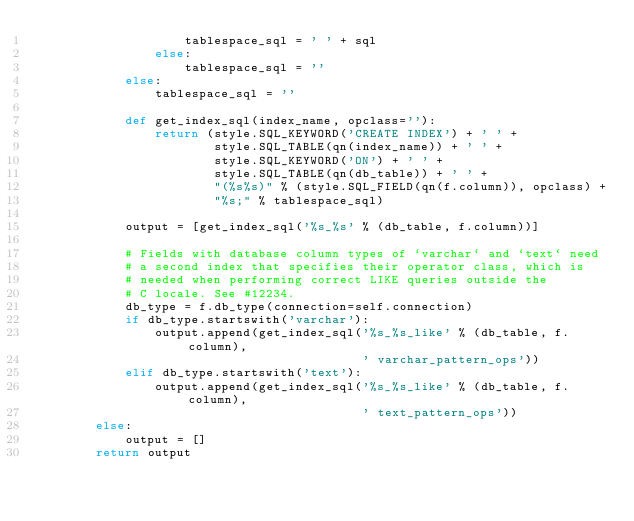<code> <loc_0><loc_0><loc_500><loc_500><_Python_>                    tablespace_sql = ' ' + sql
                else:
                    tablespace_sql = ''
            else:
                tablespace_sql = ''

            def get_index_sql(index_name, opclass=''):
                return (style.SQL_KEYWORD('CREATE INDEX') + ' ' +
                        style.SQL_TABLE(qn(index_name)) + ' ' +
                        style.SQL_KEYWORD('ON') + ' ' +
                        style.SQL_TABLE(qn(db_table)) + ' ' +
                        "(%s%s)" % (style.SQL_FIELD(qn(f.column)), opclass) +
                        "%s;" % tablespace_sql)

            output = [get_index_sql('%s_%s' % (db_table, f.column))]

            # Fields with database column types of `varchar` and `text` need
            # a second index that specifies their operator class, which is
            # needed when performing correct LIKE queries outside the
            # C locale. See #12234.
            db_type = f.db_type(connection=self.connection)
            if db_type.startswith('varchar'):
                output.append(get_index_sql('%s_%s_like' % (db_table, f.column),
                                            ' varchar_pattern_ops'))
            elif db_type.startswith('text'):
                output.append(get_index_sql('%s_%s_like' % (db_table, f.column),
                                            ' text_pattern_ops'))
        else:
            output = []
        return output
</code> 